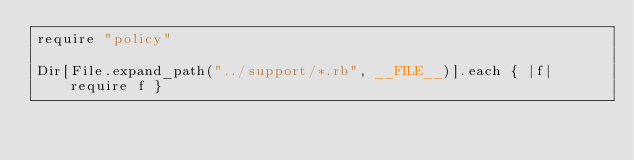Convert code to text. <code><loc_0><loc_0><loc_500><loc_500><_Ruby_>require "policy"

Dir[File.expand_path("../support/*.rb", __FILE__)].each { |f| require f }</code> 